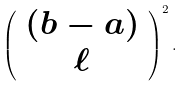Convert formula to latex. <formula><loc_0><loc_0><loc_500><loc_500>\left ( \begin{array} { c } ( b - a ) \\ \ell \end{array} \right ) ^ { 2 } .</formula> 